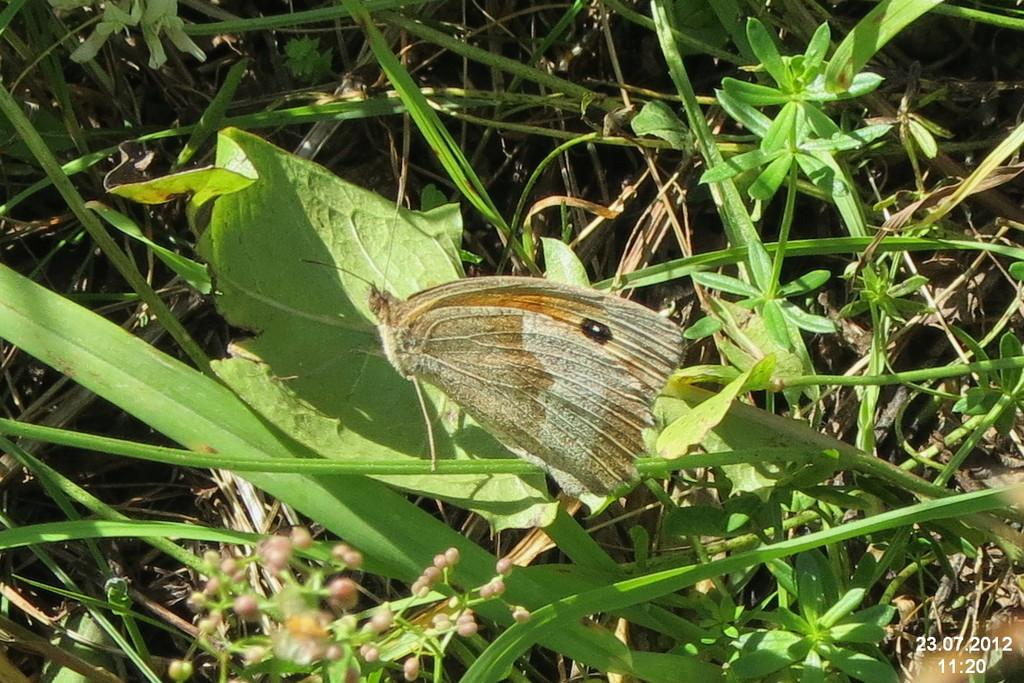What is the main subject in the foreground of the image? There is a butterfly on a leaf in the foreground of the image. What type of vegetation can be seen in the background of the image? There is grass and plants visible in the background of the image. What color is the horse's mane in the image? There is no horse present in the image; it features a butterfly on a leaf and vegetation in the background. 